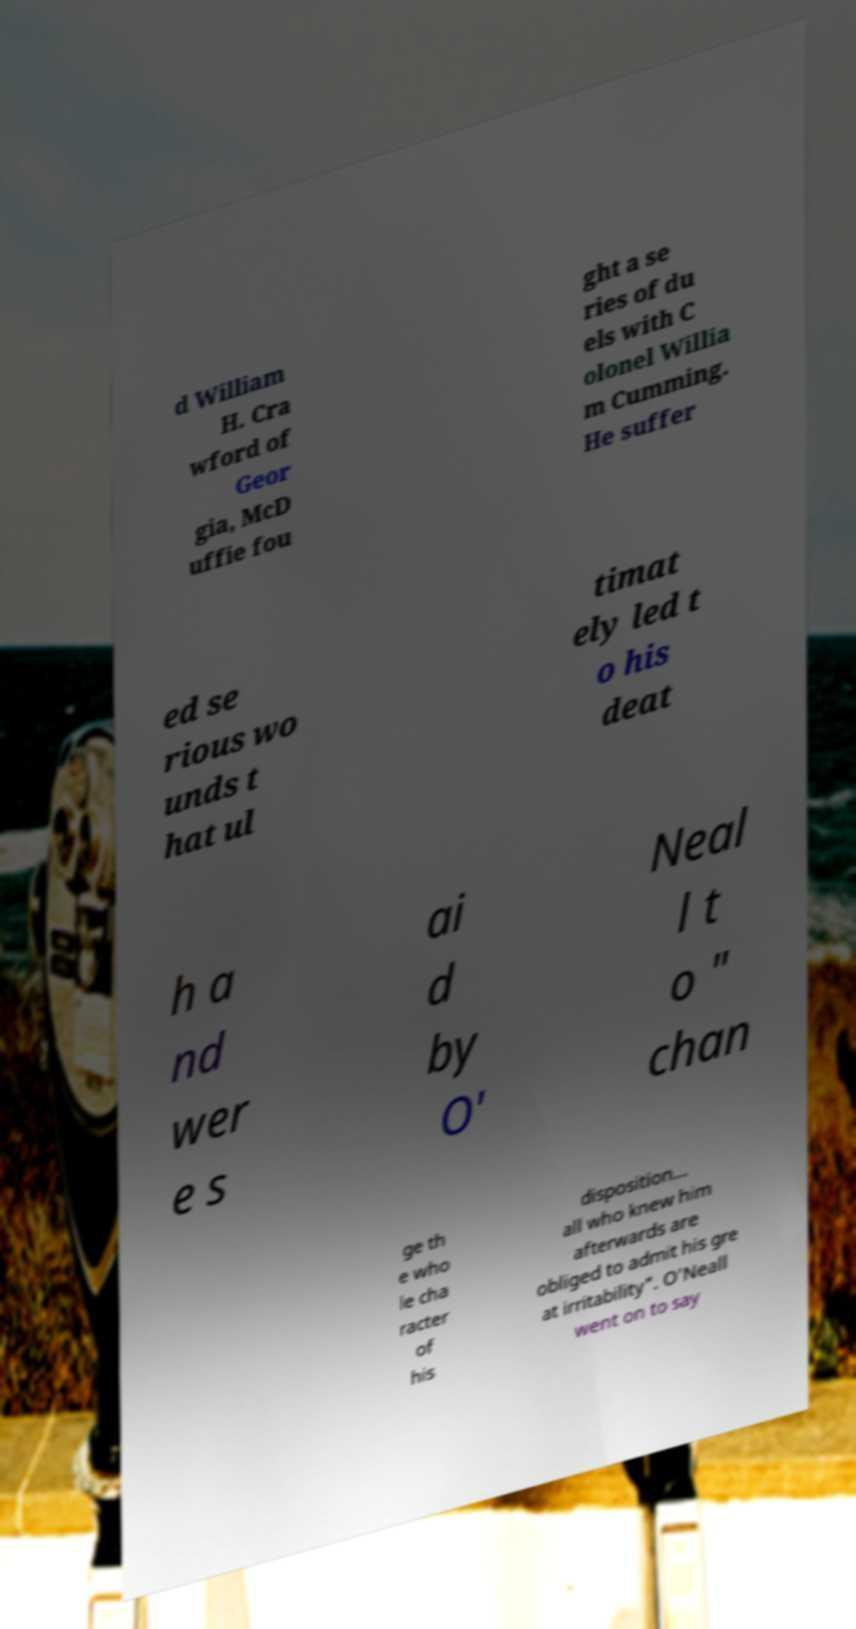Could you assist in decoding the text presented in this image and type it out clearly? d William H. Cra wford of Geor gia, McD uffie fou ght a se ries of du els with C olonel Willia m Cumming. He suffer ed se rious wo unds t hat ul timat ely led t o his deat h a nd wer e s ai d by O' Neal l t o " chan ge th e who le cha racter of his disposition... all who knew him afterwards are obliged to admit his gre at irritability". O'Neall went on to say 